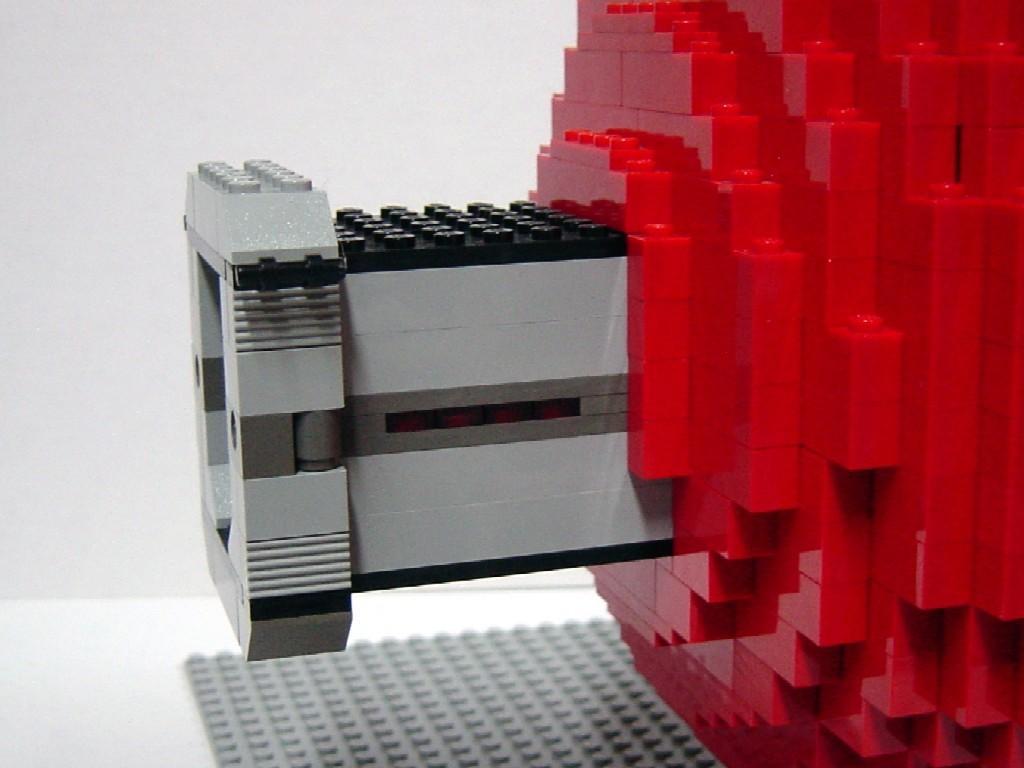Can you describe this image briefly? It is a zoomed in picture of construction set toy. We can also see the wall and floor. 